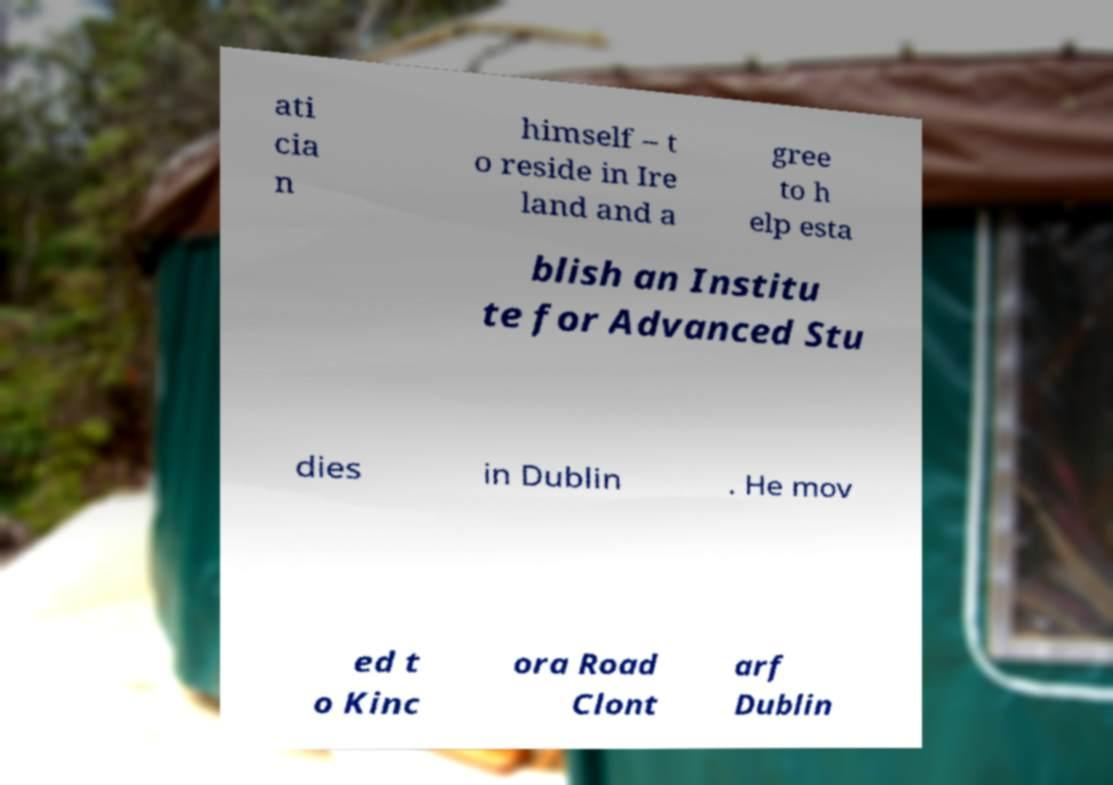Can you accurately transcribe the text from the provided image for me? ati cia n himself – t o reside in Ire land and a gree to h elp esta blish an Institu te for Advanced Stu dies in Dublin . He mov ed t o Kinc ora Road Clont arf Dublin 